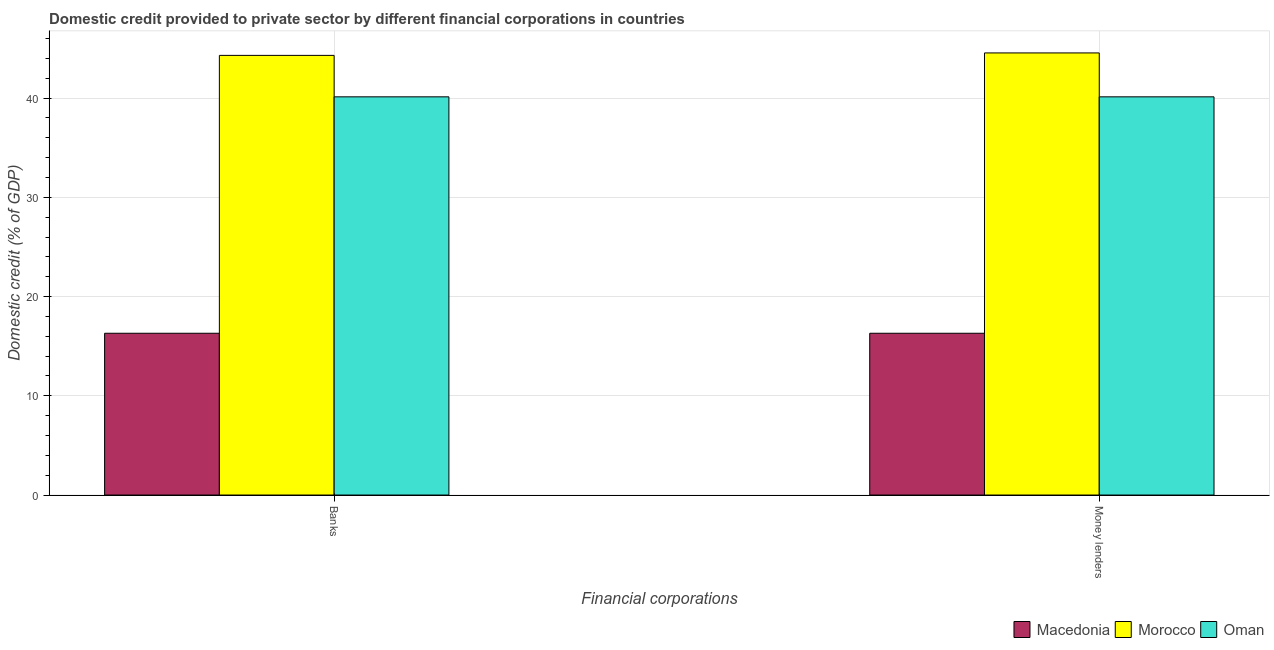How many different coloured bars are there?
Make the answer very short. 3. How many groups of bars are there?
Your response must be concise. 2. How many bars are there on the 2nd tick from the right?
Offer a very short reply. 3. What is the label of the 1st group of bars from the left?
Ensure brevity in your answer.  Banks. What is the domestic credit provided by banks in Macedonia?
Your answer should be compact. 16.3. Across all countries, what is the maximum domestic credit provided by money lenders?
Your answer should be compact. 44.55. Across all countries, what is the minimum domestic credit provided by banks?
Provide a succinct answer. 16.3. In which country was the domestic credit provided by banks maximum?
Provide a succinct answer. Morocco. In which country was the domestic credit provided by banks minimum?
Provide a succinct answer. Macedonia. What is the total domestic credit provided by banks in the graph?
Provide a short and direct response. 100.74. What is the difference between the domestic credit provided by money lenders in Macedonia and that in Morocco?
Ensure brevity in your answer.  -28.25. What is the difference between the domestic credit provided by banks in Macedonia and the domestic credit provided by money lenders in Oman?
Provide a succinct answer. -23.83. What is the average domestic credit provided by money lenders per country?
Your response must be concise. 33.66. In how many countries, is the domestic credit provided by money lenders greater than 32 %?
Ensure brevity in your answer.  2. What is the ratio of the domestic credit provided by banks in Macedonia to that in Oman?
Your response must be concise. 0.41. What does the 1st bar from the left in Banks represents?
Your answer should be compact. Macedonia. What does the 2nd bar from the right in Banks represents?
Make the answer very short. Morocco. Are the values on the major ticks of Y-axis written in scientific E-notation?
Your answer should be very brief. No. Where does the legend appear in the graph?
Provide a short and direct response. Bottom right. What is the title of the graph?
Give a very brief answer. Domestic credit provided to private sector by different financial corporations in countries. What is the label or title of the X-axis?
Offer a very short reply. Financial corporations. What is the label or title of the Y-axis?
Ensure brevity in your answer.  Domestic credit (% of GDP). What is the Domestic credit (% of GDP) in Macedonia in Banks?
Give a very brief answer. 16.3. What is the Domestic credit (% of GDP) in Morocco in Banks?
Ensure brevity in your answer.  44.31. What is the Domestic credit (% of GDP) of Oman in Banks?
Keep it short and to the point. 40.13. What is the Domestic credit (% of GDP) in Macedonia in Money lenders?
Offer a very short reply. 16.3. What is the Domestic credit (% of GDP) of Morocco in Money lenders?
Give a very brief answer. 44.55. What is the Domestic credit (% of GDP) in Oman in Money lenders?
Your answer should be very brief. 40.13. Across all Financial corporations, what is the maximum Domestic credit (% of GDP) of Macedonia?
Keep it short and to the point. 16.3. Across all Financial corporations, what is the maximum Domestic credit (% of GDP) of Morocco?
Make the answer very short. 44.55. Across all Financial corporations, what is the maximum Domestic credit (% of GDP) of Oman?
Offer a terse response. 40.13. Across all Financial corporations, what is the minimum Domestic credit (% of GDP) of Macedonia?
Your answer should be compact. 16.3. Across all Financial corporations, what is the minimum Domestic credit (% of GDP) of Morocco?
Keep it short and to the point. 44.31. Across all Financial corporations, what is the minimum Domestic credit (% of GDP) of Oman?
Your response must be concise. 40.13. What is the total Domestic credit (% of GDP) in Macedonia in the graph?
Keep it short and to the point. 32.61. What is the total Domestic credit (% of GDP) of Morocco in the graph?
Give a very brief answer. 88.86. What is the total Domestic credit (% of GDP) in Oman in the graph?
Offer a terse response. 80.26. What is the difference between the Domestic credit (% of GDP) of Morocco in Banks and that in Money lenders?
Provide a succinct answer. -0.25. What is the difference between the Domestic credit (% of GDP) in Macedonia in Banks and the Domestic credit (% of GDP) in Morocco in Money lenders?
Your answer should be very brief. -28.25. What is the difference between the Domestic credit (% of GDP) in Macedonia in Banks and the Domestic credit (% of GDP) in Oman in Money lenders?
Provide a short and direct response. -23.83. What is the difference between the Domestic credit (% of GDP) in Morocco in Banks and the Domestic credit (% of GDP) in Oman in Money lenders?
Keep it short and to the point. 4.18. What is the average Domestic credit (% of GDP) in Macedonia per Financial corporations?
Ensure brevity in your answer.  16.3. What is the average Domestic credit (% of GDP) in Morocco per Financial corporations?
Give a very brief answer. 44.43. What is the average Domestic credit (% of GDP) in Oman per Financial corporations?
Your answer should be very brief. 40.13. What is the difference between the Domestic credit (% of GDP) in Macedonia and Domestic credit (% of GDP) in Morocco in Banks?
Your answer should be very brief. -28. What is the difference between the Domestic credit (% of GDP) of Macedonia and Domestic credit (% of GDP) of Oman in Banks?
Ensure brevity in your answer.  -23.83. What is the difference between the Domestic credit (% of GDP) in Morocco and Domestic credit (% of GDP) in Oman in Banks?
Ensure brevity in your answer.  4.18. What is the difference between the Domestic credit (% of GDP) in Macedonia and Domestic credit (% of GDP) in Morocco in Money lenders?
Provide a short and direct response. -28.25. What is the difference between the Domestic credit (% of GDP) of Macedonia and Domestic credit (% of GDP) of Oman in Money lenders?
Keep it short and to the point. -23.83. What is the difference between the Domestic credit (% of GDP) of Morocco and Domestic credit (% of GDP) of Oman in Money lenders?
Offer a very short reply. 4.42. What is the ratio of the Domestic credit (% of GDP) in Morocco in Banks to that in Money lenders?
Your answer should be very brief. 0.99. What is the ratio of the Domestic credit (% of GDP) in Oman in Banks to that in Money lenders?
Give a very brief answer. 1. What is the difference between the highest and the second highest Domestic credit (% of GDP) in Morocco?
Offer a terse response. 0.25. What is the difference between the highest and the second highest Domestic credit (% of GDP) in Oman?
Ensure brevity in your answer.  0. What is the difference between the highest and the lowest Domestic credit (% of GDP) in Macedonia?
Offer a very short reply. 0. What is the difference between the highest and the lowest Domestic credit (% of GDP) in Morocco?
Keep it short and to the point. 0.25. What is the difference between the highest and the lowest Domestic credit (% of GDP) of Oman?
Your response must be concise. 0. 